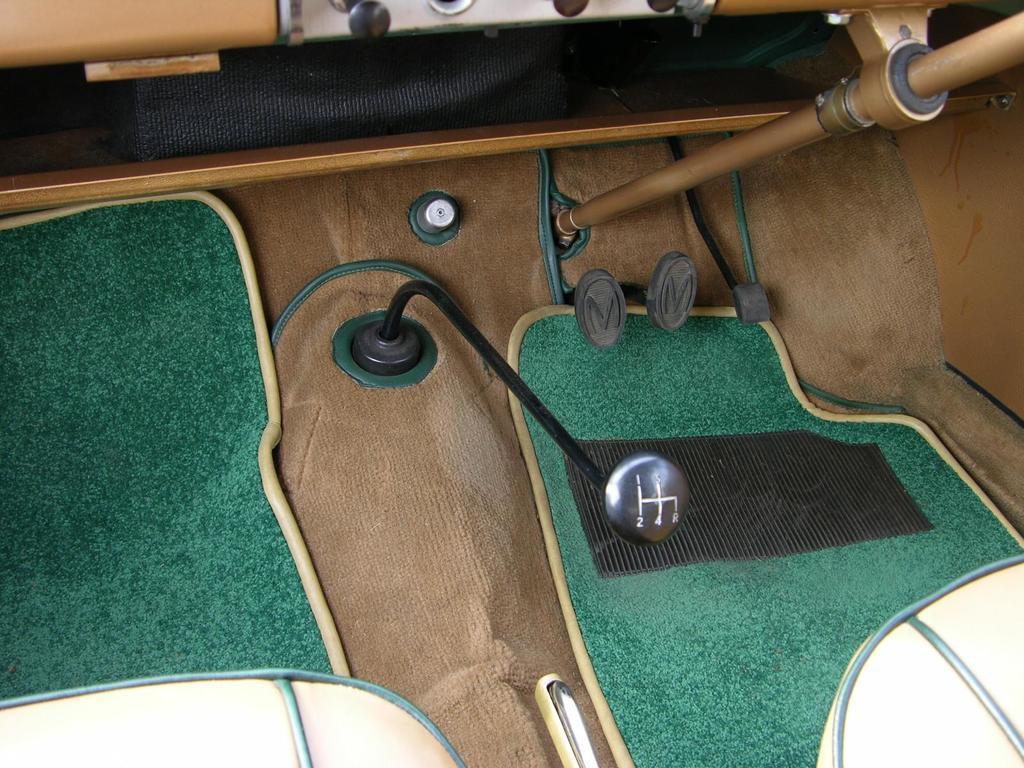Could you give a brief overview of what you see in this image? This is inside of a vehicle. There are mats, seats and gear. Also there are petals of accelerator, brake and clutch. 